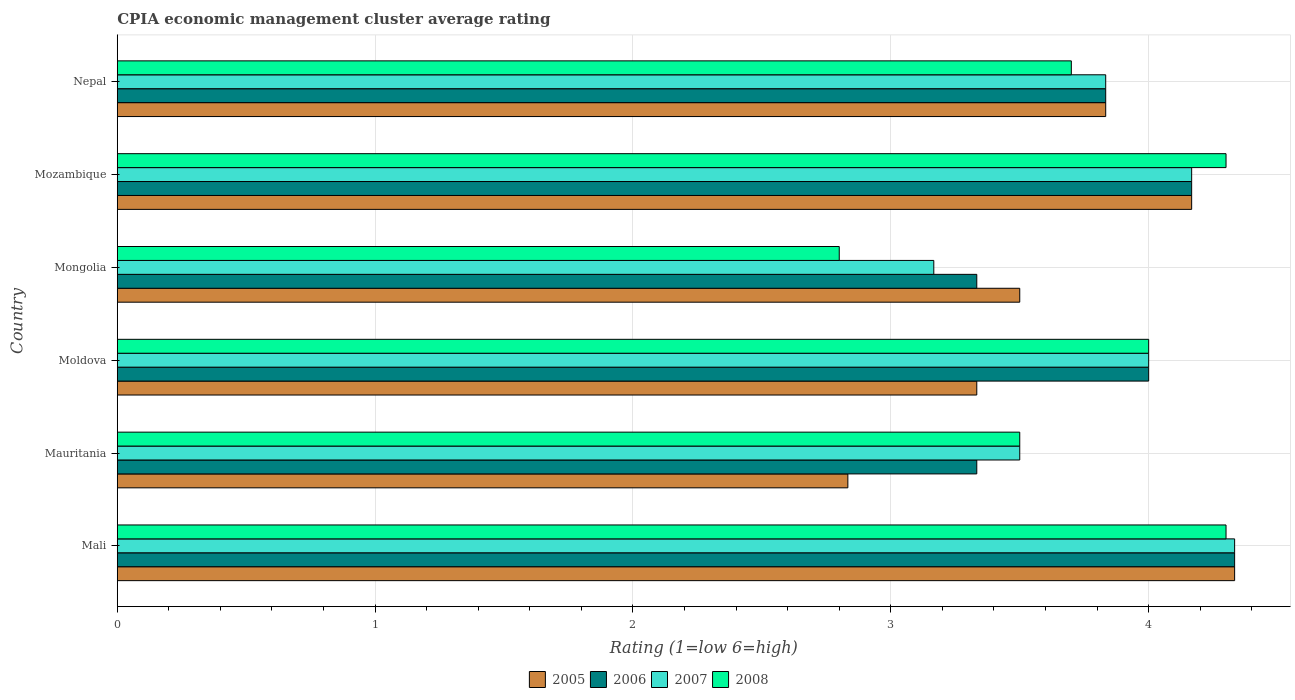How many bars are there on the 1st tick from the bottom?
Provide a succinct answer. 4. What is the label of the 5th group of bars from the top?
Your response must be concise. Mauritania. In how many cases, is the number of bars for a given country not equal to the number of legend labels?
Provide a succinct answer. 0. What is the CPIA rating in 2005 in Mozambique?
Offer a very short reply. 4.17. Across all countries, what is the maximum CPIA rating in 2005?
Provide a succinct answer. 4.33. Across all countries, what is the minimum CPIA rating in 2007?
Keep it short and to the point. 3.17. In which country was the CPIA rating in 2007 maximum?
Ensure brevity in your answer.  Mali. In which country was the CPIA rating in 2008 minimum?
Ensure brevity in your answer.  Mongolia. What is the total CPIA rating in 2008 in the graph?
Provide a succinct answer. 22.6. What is the difference between the CPIA rating in 2005 in Mali and that in Mozambique?
Keep it short and to the point. 0.17. What is the difference between the CPIA rating in 2008 in Mali and the CPIA rating in 2006 in Nepal?
Provide a succinct answer. 0.47. What is the average CPIA rating in 2005 per country?
Offer a very short reply. 3.67. What is the difference between the CPIA rating in 2007 and CPIA rating in 2005 in Mongolia?
Give a very brief answer. -0.33. In how many countries, is the CPIA rating in 2007 greater than 0.8 ?
Provide a succinct answer. 6. What is the ratio of the CPIA rating in 2007 in Mauritania to that in Nepal?
Make the answer very short. 0.91. What is the difference between the highest and the second highest CPIA rating in 2005?
Keep it short and to the point. 0.17. What is the difference between the highest and the lowest CPIA rating in 2005?
Make the answer very short. 1.5. Is it the case that in every country, the sum of the CPIA rating in 2006 and CPIA rating in 2007 is greater than the sum of CPIA rating in 2008 and CPIA rating in 2005?
Give a very brief answer. No. What does the 3rd bar from the top in Mozambique represents?
Your answer should be compact. 2006. Is it the case that in every country, the sum of the CPIA rating in 2007 and CPIA rating in 2006 is greater than the CPIA rating in 2008?
Provide a succinct answer. Yes. How many bars are there?
Give a very brief answer. 24. What is the difference between two consecutive major ticks on the X-axis?
Your answer should be very brief. 1. Are the values on the major ticks of X-axis written in scientific E-notation?
Give a very brief answer. No. How many legend labels are there?
Your answer should be very brief. 4. What is the title of the graph?
Provide a succinct answer. CPIA economic management cluster average rating. What is the label or title of the Y-axis?
Provide a succinct answer. Country. What is the Rating (1=low 6=high) of 2005 in Mali?
Give a very brief answer. 4.33. What is the Rating (1=low 6=high) in 2006 in Mali?
Provide a succinct answer. 4.33. What is the Rating (1=low 6=high) in 2007 in Mali?
Offer a terse response. 4.33. What is the Rating (1=low 6=high) in 2005 in Mauritania?
Keep it short and to the point. 2.83. What is the Rating (1=low 6=high) of 2006 in Mauritania?
Keep it short and to the point. 3.33. What is the Rating (1=low 6=high) in 2008 in Mauritania?
Provide a succinct answer. 3.5. What is the Rating (1=low 6=high) of 2005 in Moldova?
Ensure brevity in your answer.  3.33. What is the Rating (1=low 6=high) in 2006 in Moldova?
Your answer should be compact. 4. What is the Rating (1=low 6=high) in 2008 in Moldova?
Offer a very short reply. 4. What is the Rating (1=low 6=high) of 2005 in Mongolia?
Provide a succinct answer. 3.5. What is the Rating (1=low 6=high) in 2006 in Mongolia?
Ensure brevity in your answer.  3.33. What is the Rating (1=low 6=high) in 2007 in Mongolia?
Make the answer very short. 3.17. What is the Rating (1=low 6=high) of 2005 in Mozambique?
Offer a terse response. 4.17. What is the Rating (1=low 6=high) in 2006 in Mozambique?
Make the answer very short. 4.17. What is the Rating (1=low 6=high) of 2007 in Mozambique?
Ensure brevity in your answer.  4.17. What is the Rating (1=low 6=high) of 2005 in Nepal?
Offer a very short reply. 3.83. What is the Rating (1=low 6=high) of 2006 in Nepal?
Provide a succinct answer. 3.83. What is the Rating (1=low 6=high) in 2007 in Nepal?
Your answer should be very brief. 3.83. What is the Rating (1=low 6=high) of 2008 in Nepal?
Give a very brief answer. 3.7. Across all countries, what is the maximum Rating (1=low 6=high) of 2005?
Your answer should be very brief. 4.33. Across all countries, what is the maximum Rating (1=low 6=high) of 2006?
Offer a very short reply. 4.33. Across all countries, what is the maximum Rating (1=low 6=high) in 2007?
Your answer should be very brief. 4.33. Across all countries, what is the maximum Rating (1=low 6=high) in 2008?
Ensure brevity in your answer.  4.3. Across all countries, what is the minimum Rating (1=low 6=high) of 2005?
Make the answer very short. 2.83. Across all countries, what is the minimum Rating (1=low 6=high) of 2006?
Provide a succinct answer. 3.33. Across all countries, what is the minimum Rating (1=low 6=high) in 2007?
Offer a terse response. 3.17. Across all countries, what is the minimum Rating (1=low 6=high) of 2008?
Your response must be concise. 2.8. What is the total Rating (1=low 6=high) of 2005 in the graph?
Your answer should be very brief. 22. What is the total Rating (1=low 6=high) in 2008 in the graph?
Keep it short and to the point. 22.6. What is the difference between the Rating (1=low 6=high) of 2006 in Mali and that in Mauritania?
Give a very brief answer. 1. What is the difference between the Rating (1=low 6=high) in 2007 in Mali and that in Mauritania?
Provide a short and direct response. 0.83. What is the difference between the Rating (1=low 6=high) of 2005 in Mali and that in Moldova?
Keep it short and to the point. 1. What is the difference between the Rating (1=low 6=high) of 2006 in Mali and that in Moldova?
Keep it short and to the point. 0.33. What is the difference between the Rating (1=low 6=high) in 2005 in Mali and that in Mongolia?
Your answer should be compact. 0.83. What is the difference between the Rating (1=low 6=high) in 2007 in Mali and that in Mongolia?
Provide a succinct answer. 1.17. What is the difference between the Rating (1=low 6=high) in 2006 in Mali and that in Mozambique?
Your answer should be very brief. 0.17. What is the difference between the Rating (1=low 6=high) in 2007 in Mali and that in Nepal?
Offer a terse response. 0.5. What is the difference between the Rating (1=low 6=high) of 2008 in Mali and that in Nepal?
Your response must be concise. 0.6. What is the difference between the Rating (1=low 6=high) of 2006 in Mauritania and that in Mongolia?
Ensure brevity in your answer.  0. What is the difference between the Rating (1=low 6=high) in 2005 in Mauritania and that in Mozambique?
Offer a very short reply. -1.33. What is the difference between the Rating (1=low 6=high) in 2007 in Mauritania and that in Nepal?
Give a very brief answer. -0.33. What is the difference between the Rating (1=low 6=high) of 2006 in Moldova and that in Mongolia?
Ensure brevity in your answer.  0.67. What is the difference between the Rating (1=low 6=high) of 2007 in Moldova and that in Mongolia?
Your answer should be very brief. 0.83. What is the difference between the Rating (1=low 6=high) of 2005 in Moldova and that in Mozambique?
Your response must be concise. -0.83. What is the difference between the Rating (1=low 6=high) of 2007 in Moldova and that in Mozambique?
Your answer should be very brief. -0.17. What is the difference between the Rating (1=low 6=high) in 2008 in Moldova and that in Mozambique?
Provide a succinct answer. -0.3. What is the difference between the Rating (1=low 6=high) of 2005 in Moldova and that in Nepal?
Offer a very short reply. -0.5. What is the difference between the Rating (1=low 6=high) in 2006 in Moldova and that in Nepal?
Your answer should be compact. 0.17. What is the difference between the Rating (1=low 6=high) in 2008 in Moldova and that in Nepal?
Your answer should be compact. 0.3. What is the difference between the Rating (1=low 6=high) in 2005 in Mongolia and that in Mozambique?
Offer a terse response. -0.67. What is the difference between the Rating (1=low 6=high) of 2007 in Mongolia and that in Mozambique?
Keep it short and to the point. -1. What is the difference between the Rating (1=low 6=high) of 2005 in Mali and the Rating (1=low 6=high) of 2006 in Mauritania?
Your answer should be compact. 1. What is the difference between the Rating (1=low 6=high) of 2005 in Mali and the Rating (1=low 6=high) of 2007 in Mauritania?
Ensure brevity in your answer.  0.83. What is the difference between the Rating (1=low 6=high) in 2006 in Mali and the Rating (1=low 6=high) in 2007 in Mauritania?
Your response must be concise. 0.83. What is the difference between the Rating (1=low 6=high) in 2006 in Mali and the Rating (1=low 6=high) in 2008 in Mauritania?
Your answer should be very brief. 0.83. What is the difference between the Rating (1=low 6=high) in 2007 in Mali and the Rating (1=low 6=high) in 2008 in Mauritania?
Offer a terse response. 0.83. What is the difference between the Rating (1=low 6=high) in 2005 in Mali and the Rating (1=low 6=high) in 2007 in Moldova?
Your answer should be very brief. 0.33. What is the difference between the Rating (1=low 6=high) in 2006 in Mali and the Rating (1=low 6=high) in 2008 in Moldova?
Ensure brevity in your answer.  0.33. What is the difference between the Rating (1=low 6=high) in 2007 in Mali and the Rating (1=low 6=high) in 2008 in Moldova?
Offer a terse response. 0.33. What is the difference between the Rating (1=low 6=high) in 2005 in Mali and the Rating (1=low 6=high) in 2006 in Mongolia?
Offer a terse response. 1. What is the difference between the Rating (1=low 6=high) in 2005 in Mali and the Rating (1=low 6=high) in 2008 in Mongolia?
Keep it short and to the point. 1.53. What is the difference between the Rating (1=low 6=high) of 2006 in Mali and the Rating (1=low 6=high) of 2007 in Mongolia?
Offer a terse response. 1.17. What is the difference between the Rating (1=low 6=high) of 2006 in Mali and the Rating (1=low 6=high) of 2008 in Mongolia?
Give a very brief answer. 1.53. What is the difference between the Rating (1=low 6=high) in 2007 in Mali and the Rating (1=low 6=high) in 2008 in Mongolia?
Your response must be concise. 1.53. What is the difference between the Rating (1=low 6=high) of 2005 in Mali and the Rating (1=low 6=high) of 2006 in Mozambique?
Make the answer very short. 0.17. What is the difference between the Rating (1=low 6=high) in 2005 in Mali and the Rating (1=low 6=high) in 2007 in Mozambique?
Your answer should be very brief. 0.17. What is the difference between the Rating (1=low 6=high) of 2006 in Mali and the Rating (1=low 6=high) of 2007 in Mozambique?
Provide a short and direct response. 0.17. What is the difference between the Rating (1=low 6=high) in 2005 in Mali and the Rating (1=low 6=high) in 2007 in Nepal?
Offer a very short reply. 0.5. What is the difference between the Rating (1=low 6=high) of 2005 in Mali and the Rating (1=low 6=high) of 2008 in Nepal?
Your answer should be very brief. 0.63. What is the difference between the Rating (1=low 6=high) of 2006 in Mali and the Rating (1=low 6=high) of 2007 in Nepal?
Your answer should be compact. 0.5. What is the difference between the Rating (1=low 6=high) of 2006 in Mali and the Rating (1=low 6=high) of 2008 in Nepal?
Your response must be concise. 0.63. What is the difference between the Rating (1=low 6=high) of 2007 in Mali and the Rating (1=low 6=high) of 2008 in Nepal?
Offer a terse response. 0.63. What is the difference between the Rating (1=low 6=high) in 2005 in Mauritania and the Rating (1=low 6=high) in 2006 in Moldova?
Provide a succinct answer. -1.17. What is the difference between the Rating (1=low 6=high) in 2005 in Mauritania and the Rating (1=low 6=high) in 2007 in Moldova?
Your answer should be compact. -1.17. What is the difference between the Rating (1=low 6=high) in 2005 in Mauritania and the Rating (1=low 6=high) in 2008 in Moldova?
Provide a succinct answer. -1.17. What is the difference between the Rating (1=low 6=high) of 2006 in Mauritania and the Rating (1=low 6=high) of 2007 in Moldova?
Offer a very short reply. -0.67. What is the difference between the Rating (1=low 6=high) of 2006 in Mauritania and the Rating (1=low 6=high) of 2008 in Moldova?
Provide a short and direct response. -0.67. What is the difference between the Rating (1=low 6=high) in 2005 in Mauritania and the Rating (1=low 6=high) in 2007 in Mongolia?
Your response must be concise. -0.33. What is the difference between the Rating (1=low 6=high) of 2005 in Mauritania and the Rating (1=low 6=high) of 2008 in Mongolia?
Your answer should be very brief. 0.03. What is the difference between the Rating (1=low 6=high) of 2006 in Mauritania and the Rating (1=low 6=high) of 2008 in Mongolia?
Provide a succinct answer. 0.53. What is the difference between the Rating (1=low 6=high) in 2005 in Mauritania and the Rating (1=low 6=high) in 2006 in Mozambique?
Your answer should be compact. -1.33. What is the difference between the Rating (1=low 6=high) of 2005 in Mauritania and the Rating (1=low 6=high) of 2007 in Mozambique?
Your answer should be compact. -1.33. What is the difference between the Rating (1=low 6=high) of 2005 in Mauritania and the Rating (1=low 6=high) of 2008 in Mozambique?
Offer a very short reply. -1.47. What is the difference between the Rating (1=low 6=high) in 2006 in Mauritania and the Rating (1=low 6=high) in 2007 in Mozambique?
Provide a short and direct response. -0.83. What is the difference between the Rating (1=low 6=high) of 2006 in Mauritania and the Rating (1=low 6=high) of 2008 in Mozambique?
Keep it short and to the point. -0.97. What is the difference between the Rating (1=low 6=high) in 2007 in Mauritania and the Rating (1=low 6=high) in 2008 in Mozambique?
Your response must be concise. -0.8. What is the difference between the Rating (1=low 6=high) of 2005 in Mauritania and the Rating (1=low 6=high) of 2006 in Nepal?
Give a very brief answer. -1. What is the difference between the Rating (1=low 6=high) of 2005 in Mauritania and the Rating (1=low 6=high) of 2007 in Nepal?
Your response must be concise. -1. What is the difference between the Rating (1=low 6=high) in 2005 in Mauritania and the Rating (1=low 6=high) in 2008 in Nepal?
Keep it short and to the point. -0.87. What is the difference between the Rating (1=low 6=high) in 2006 in Mauritania and the Rating (1=low 6=high) in 2008 in Nepal?
Offer a terse response. -0.37. What is the difference between the Rating (1=low 6=high) of 2007 in Mauritania and the Rating (1=low 6=high) of 2008 in Nepal?
Keep it short and to the point. -0.2. What is the difference between the Rating (1=low 6=high) in 2005 in Moldova and the Rating (1=low 6=high) in 2006 in Mongolia?
Your answer should be very brief. 0. What is the difference between the Rating (1=low 6=high) in 2005 in Moldova and the Rating (1=low 6=high) in 2007 in Mongolia?
Your response must be concise. 0.17. What is the difference between the Rating (1=low 6=high) of 2005 in Moldova and the Rating (1=low 6=high) of 2008 in Mongolia?
Ensure brevity in your answer.  0.53. What is the difference between the Rating (1=low 6=high) in 2006 in Moldova and the Rating (1=low 6=high) in 2007 in Mongolia?
Give a very brief answer. 0.83. What is the difference between the Rating (1=low 6=high) of 2007 in Moldova and the Rating (1=low 6=high) of 2008 in Mongolia?
Make the answer very short. 1.2. What is the difference between the Rating (1=low 6=high) of 2005 in Moldova and the Rating (1=low 6=high) of 2006 in Mozambique?
Offer a very short reply. -0.83. What is the difference between the Rating (1=low 6=high) in 2005 in Moldova and the Rating (1=low 6=high) in 2008 in Mozambique?
Keep it short and to the point. -0.97. What is the difference between the Rating (1=low 6=high) of 2005 in Moldova and the Rating (1=low 6=high) of 2006 in Nepal?
Offer a very short reply. -0.5. What is the difference between the Rating (1=low 6=high) of 2005 in Moldova and the Rating (1=low 6=high) of 2008 in Nepal?
Make the answer very short. -0.37. What is the difference between the Rating (1=low 6=high) in 2005 in Mongolia and the Rating (1=low 6=high) in 2006 in Mozambique?
Your answer should be compact. -0.67. What is the difference between the Rating (1=low 6=high) of 2005 in Mongolia and the Rating (1=low 6=high) of 2007 in Mozambique?
Keep it short and to the point. -0.67. What is the difference between the Rating (1=low 6=high) of 2006 in Mongolia and the Rating (1=low 6=high) of 2007 in Mozambique?
Offer a terse response. -0.83. What is the difference between the Rating (1=low 6=high) of 2006 in Mongolia and the Rating (1=low 6=high) of 2008 in Mozambique?
Keep it short and to the point. -0.97. What is the difference between the Rating (1=low 6=high) in 2007 in Mongolia and the Rating (1=low 6=high) in 2008 in Mozambique?
Your answer should be compact. -1.13. What is the difference between the Rating (1=low 6=high) in 2005 in Mongolia and the Rating (1=low 6=high) in 2006 in Nepal?
Your response must be concise. -0.33. What is the difference between the Rating (1=low 6=high) of 2005 in Mongolia and the Rating (1=low 6=high) of 2007 in Nepal?
Your answer should be very brief. -0.33. What is the difference between the Rating (1=low 6=high) of 2005 in Mongolia and the Rating (1=low 6=high) of 2008 in Nepal?
Offer a very short reply. -0.2. What is the difference between the Rating (1=low 6=high) in 2006 in Mongolia and the Rating (1=low 6=high) in 2007 in Nepal?
Give a very brief answer. -0.5. What is the difference between the Rating (1=low 6=high) in 2006 in Mongolia and the Rating (1=low 6=high) in 2008 in Nepal?
Provide a short and direct response. -0.37. What is the difference between the Rating (1=low 6=high) of 2007 in Mongolia and the Rating (1=low 6=high) of 2008 in Nepal?
Ensure brevity in your answer.  -0.53. What is the difference between the Rating (1=low 6=high) of 2005 in Mozambique and the Rating (1=low 6=high) of 2007 in Nepal?
Offer a very short reply. 0.33. What is the difference between the Rating (1=low 6=high) in 2005 in Mozambique and the Rating (1=low 6=high) in 2008 in Nepal?
Your response must be concise. 0.47. What is the difference between the Rating (1=low 6=high) of 2006 in Mozambique and the Rating (1=low 6=high) of 2008 in Nepal?
Your answer should be compact. 0.47. What is the difference between the Rating (1=low 6=high) in 2007 in Mozambique and the Rating (1=low 6=high) in 2008 in Nepal?
Offer a terse response. 0.47. What is the average Rating (1=low 6=high) in 2005 per country?
Make the answer very short. 3.67. What is the average Rating (1=low 6=high) in 2006 per country?
Your answer should be compact. 3.83. What is the average Rating (1=low 6=high) of 2007 per country?
Keep it short and to the point. 3.83. What is the average Rating (1=low 6=high) of 2008 per country?
Offer a very short reply. 3.77. What is the difference between the Rating (1=low 6=high) of 2005 and Rating (1=low 6=high) of 2008 in Mali?
Keep it short and to the point. 0.03. What is the difference between the Rating (1=low 6=high) of 2005 and Rating (1=low 6=high) of 2008 in Mauritania?
Offer a terse response. -0.67. What is the difference between the Rating (1=low 6=high) in 2006 and Rating (1=low 6=high) in 2007 in Mauritania?
Ensure brevity in your answer.  -0.17. What is the difference between the Rating (1=low 6=high) of 2005 and Rating (1=low 6=high) of 2008 in Moldova?
Offer a terse response. -0.67. What is the difference between the Rating (1=low 6=high) in 2006 and Rating (1=low 6=high) in 2007 in Moldova?
Your answer should be compact. 0. What is the difference between the Rating (1=low 6=high) in 2007 and Rating (1=low 6=high) in 2008 in Moldova?
Keep it short and to the point. 0. What is the difference between the Rating (1=low 6=high) of 2005 and Rating (1=low 6=high) of 2007 in Mongolia?
Offer a very short reply. 0.33. What is the difference between the Rating (1=low 6=high) of 2006 and Rating (1=low 6=high) of 2008 in Mongolia?
Your response must be concise. 0.53. What is the difference between the Rating (1=low 6=high) of 2007 and Rating (1=low 6=high) of 2008 in Mongolia?
Your response must be concise. 0.37. What is the difference between the Rating (1=low 6=high) of 2005 and Rating (1=low 6=high) of 2006 in Mozambique?
Provide a short and direct response. 0. What is the difference between the Rating (1=low 6=high) in 2005 and Rating (1=low 6=high) in 2008 in Mozambique?
Your response must be concise. -0.13. What is the difference between the Rating (1=low 6=high) of 2006 and Rating (1=low 6=high) of 2008 in Mozambique?
Your answer should be compact. -0.13. What is the difference between the Rating (1=low 6=high) of 2007 and Rating (1=low 6=high) of 2008 in Mozambique?
Offer a very short reply. -0.13. What is the difference between the Rating (1=low 6=high) in 2005 and Rating (1=low 6=high) in 2006 in Nepal?
Keep it short and to the point. 0. What is the difference between the Rating (1=low 6=high) in 2005 and Rating (1=low 6=high) in 2007 in Nepal?
Offer a terse response. 0. What is the difference between the Rating (1=low 6=high) in 2005 and Rating (1=low 6=high) in 2008 in Nepal?
Ensure brevity in your answer.  0.13. What is the difference between the Rating (1=low 6=high) in 2006 and Rating (1=low 6=high) in 2007 in Nepal?
Your answer should be very brief. 0. What is the difference between the Rating (1=low 6=high) in 2006 and Rating (1=low 6=high) in 2008 in Nepal?
Give a very brief answer. 0.13. What is the difference between the Rating (1=low 6=high) in 2007 and Rating (1=low 6=high) in 2008 in Nepal?
Your response must be concise. 0.13. What is the ratio of the Rating (1=low 6=high) in 2005 in Mali to that in Mauritania?
Provide a succinct answer. 1.53. What is the ratio of the Rating (1=low 6=high) of 2006 in Mali to that in Mauritania?
Provide a succinct answer. 1.3. What is the ratio of the Rating (1=low 6=high) in 2007 in Mali to that in Mauritania?
Offer a terse response. 1.24. What is the ratio of the Rating (1=low 6=high) in 2008 in Mali to that in Mauritania?
Your answer should be very brief. 1.23. What is the ratio of the Rating (1=low 6=high) of 2005 in Mali to that in Moldova?
Provide a succinct answer. 1.3. What is the ratio of the Rating (1=low 6=high) of 2008 in Mali to that in Moldova?
Give a very brief answer. 1.07. What is the ratio of the Rating (1=low 6=high) in 2005 in Mali to that in Mongolia?
Your answer should be very brief. 1.24. What is the ratio of the Rating (1=low 6=high) in 2007 in Mali to that in Mongolia?
Make the answer very short. 1.37. What is the ratio of the Rating (1=low 6=high) of 2008 in Mali to that in Mongolia?
Your answer should be very brief. 1.54. What is the ratio of the Rating (1=low 6=high) of 2007 in Mali to that in Mozambique?
Keep it short and to the point. 1.04. What is the ratio of the Rating (1=low 6=high) of 2005 in Mali to that in Nepal?
Give a very brief answer. 1.13. What is the ratio of the Rating (1=low 6=high) of 2006 in Mali to that in Nepal?
Give a very brief answer. 1.13. What is the ratio of the Rating (1=low 6=high) of 2007 in Mali to that in Nepal?
Your answer should be compact. 1.13. What is the ratio of the Rating (1=low 6=high) of 2008 in Mali to that in Nepal?
Provide a succinct answer. 1.16. What is the ratio of the Rating (1=low 6=high) in 2005 in Mauritania to that in Moldova?
Keep it short and to the point. 0.85. What is the ratio of the Rating (1=low 6=high) in 2007 in Mauritania to that in Moldova?
Your answer should be very brief. 0.88. What is the ratio of the Rating (1=low 6=high) in 2008 in Mauritania to that in Moldova?
Your answer should be compact. 0.88. What is the ratio of the Rating (1=low 6=high) in 2005 in Mauritania to that in Mongolia?
Make the answer very short. 0.81. What is the ratio of the Rating (1=low 6=high) in 2006 in Mauritania to that in Mongolia?
Ensure brevity in your answer.  1. What is the ratio of the Rating (1=low 6=high) in 2007 in Mauritania to that in Mongolia?
Your answer should be very brief. 1.11. What is the ratio of the Rating (1=low 6=high) in 2005 in Mauritania to that in Mozambique?
Make the answer very short. 0.68. What is the ratio of the Rating (1=low 6=high) of 2006 in Mauritania to that in Mozambique?
Make the answer very short. 0.8. What is the ratio of the Rating (1=low 6=high) of 2007 in Mauritania to that in Mozambique?
Ensure brevity in your answer.  0.84. What is the ratio of the Rating (1=low 6=high) in 2008 in Mauritania to that in Mozambique?
Give a very brief answer. 0.81. What is the ratio of the Rating (1=low 6=high) of 2005 in Mauritania to that in Nepal?
Offer a very short reply. 0.74. What is the ratio of the Rating (1=low 6=high) in 2006 in Mauritania to that in Nepal?
Offer a very short reply. 0.87. What is the ratio of the Rating (1=low 6=high) in 2008 in Mauritania to that in Nepal?
Offer a very short reply. 0.95. What is the ratio of the Rating (1=low 6=high) of 2005 in Moldova to that in Mongolia?
Your answer should be very brief. 0.95. What is the ratio of the Rating (1=low 6=high) in 2006 in Moldova to that in Mongolia?
Your answer should be compact. 1.2. What is the ratio of the Rating (1=low 6=high) in 2007 in Moldova to that in Mongolia?
Your answer should be very brief. 1.26. What is the ratio of the Rating (1=low 6=high) of 2008 in Moldova to that in Mongolia?
Ensure brevity in your answer.  1.43. What is the ratio of the Rating (1=low 6=high) in 2005 in Moldova to that in Mozambique?
Offer a terse response. 0.8. What is the ratio of the Rating (1=low 6=high) in 2008 in Moldova to that in Mozambique?
Provide a succinct answer. 0.93. What is the ratio of the Rating (1=low 6=high) in 2005 in Moldova to that in Nepal?
Your answer should be compact. 0.87. What is the ratio of the Rating (1=low 6=high) in 2006 in Moldova to that in Nepal?
Provide a succinct answer. 1.04. What is the ratio of the Rating (1=low 6=high) in 2007 in Moldova to that in Nepal?
Make the answer very short. 1.04. What is the ratio of the Rating (1=low 6=high) of 2008 in Moldova to that in Nepal?
Offer a terse response. 1.08. What is the ratio of the Rating (1=low 6=high) in 2005 in Mongolia to that in Mozambique?
Offer a very short reply. 0.84. What is the ratio of the Rating (1=low 6=high) of 2007 in Mongolia to that in Mozambique?
Make the answer very short. 0.76. What is the ratio of the Rating (1=low 6=high) of 2008 in Mongolia to that in Mozambique?
Ensure brevity in your answer.  0.65. What is the ratio of the Rating (1=low 6=high) in 2006 in Mongolia to that in Nepal?
Your response must be concise. 0.87. What is the ratio of the Rating (1=low 6=high) of 2007 in Mongolia to that in Nepal?
Your answer should be very brief. 0.83. What is the ratio of the Rating (1=low 6=high) in 2008 in Mongolia to that in Nepal?
Give a very brief answer. 0.76. What is the ratio of the Rating (1=low 6=high) of 2005 in Mozambique to that in Nepal?
Make the answer very short. 1.09. What is the ratio of the Rating (1=low 6=high) in 2006 in Mozambique to that in Nepal?
Your response must be concise. 1.09. What is the ratio of the Rating (1=low 6=high) of 2007 in Mozambique to that in Nepal?
Your response must be concise. 1.09. What is the ratio of the Rating (1=low 6=high) of 2008 in Mozambique to that in Nepal?
Provide a succinct answer. 1.16. What is the difference between the highest and the second highest Rating (1=low 6=high) of 2006?
Provide a succinct answer. 0.17. What is the difference between the highest and the second highest Rating (1=low 6=high) in 2007?
Your answer should be very brief. 0.17. What is the difference between the highest and the second highest Rating (1=low 6=high) of 2008?
Offer a terse response. 0. 